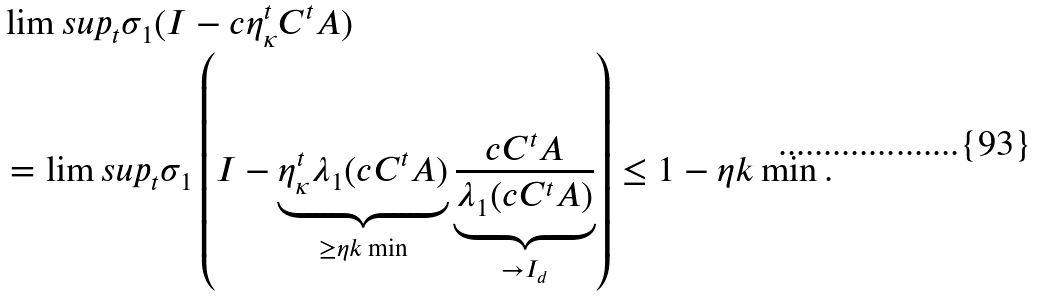<formula> <loc_0><loc_0><loc_500><loc_500>& \lim s u p _ { t } \sigma _ { 1 } ( I - c \eta _ { \kappa } ^ { t } C ^ { t } A ) \\ & = \lim s u p _ { t } \sigma _ { 1 } \left ( I - \underbrace { \eta _ { \kappa } ^ { t } \lambda _ { 1 } ( c C ^ { t } A ) } _ { \geq \eta k \min } \underbrace { \frac { c C ^ { t } A } { \lambda _ { 1 } ( c C ^ { t } A ) } } _ { \to I _ { d } } \right ) \leq 1 - \eta k \min .</formula> 